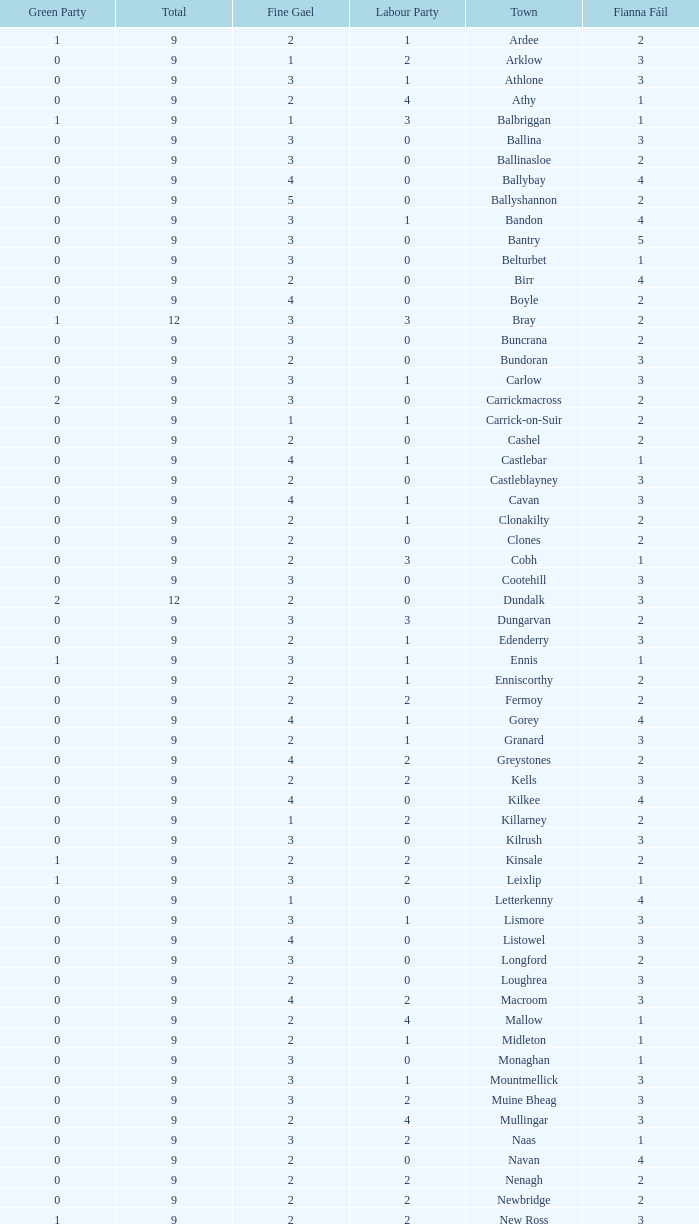How many are in the Labour Party of a Fianna Fail of 3 with a total higher than 9 and more than 2 in the Green Party? None. Could you parse the entire table as a dict? {'header': ['Green Party', 'Total', 'Fine Gael', 'Labour Party', 'Town', 'Fianna Fáil'], 'rows': [['1', '9', '2', '1', 'Ardee', '2'], ['0', '9', '1', '2', 'Arklow', '3'], ['0', '9', '3', '1', 'Athlone', '3'], ['0', '9', '2', '4', 'Athy', '1'], ['1', '9', '1', '3', 'Balbriggan', '1'], ['0', '9', '3', '0', 'Ballina', '3'], ['0', '9', '3', '0', 'Ballinasloe', '2'], ['0', '9', '4', '0', 'Ballybay', '4'], ['0', '9', '5', '0', 'Ballyshannon', '2'], ['0', '9', '3', '1', 'Bandon', '4'], ['0', '9', '3', '0', 'Bantry', '5'], ['0', '9', '3', '0', 'Belturbet', '1'], ['0', '9', '2', '0', 'Birr', '4'], ['0', '9', '4', '0', 'Boyle', '2'], ['1', '12', '3', '3', 'Bray', '2'], ['0', '9', '3', '0', 'Buncrana', '2'], ['0', '9', '2', '0', 'Bundoran', '3'], ['0', '9', '3', '1', 'Carlow', '3'], ['2', '9', '3', '0', 'Carrickmacross', '2'], ['0', '9', '1', '1', 'Carrick-on-Suir', '2'], ['0', '9', '2', '0', 'Cashel', '2'], ['0', '9', '4', '1', 'Castlebar', '1'], ['0', '9', '2', '0', 'Castleblayney', '3'], ['0', '9', '4', '1', 'Cavan', '3'], ['0', '9', '2', '1', 'Clonakilty', '2'], ['0', '9', '2', '0', 'Clones', '2'], ['0', '9', '2', '3', 'Cobh', '1'], ['0', '9', '3', '0', 'Cootehill', '3'], ['2', '12', '2', '0', 'Dundalk', '3'], ['0', '9', '3', '3', 'Dungarvan', '2'], ['0', '9', '2', '1', 'Edenderry', '3'], ['1', '9', '3', '1', 'Ennis', '1'], ['0', '9', '2', '1', 'Enniscorthy', '2'], ['0', '9', '2', '2', 'Fermoy', '2'], ['0', '9', '4', '1', 'Gorey', '4'], ['0', '9', '2', '1', 'Granard', '3'], ['0', '9', '4', '2', 'Greystones', '2'], ['0', '9', '2', '2', 'Kells', '3'], ['0', '9', '4', '0', 'Kilkee', '4'], ['0', '9', '1', '2', 'Killarney', '2'], ['0', '9', '3', '0', 'Kilrush', '3'], ['1', '9', '2', '2', 'Kinsale', '2'], ['1', '9', '3', '2', 'Leixlip', '1'], ['0', '9', '1', '0', 'Letterkenny', '4'], ['0', '9', '3', '1', 'Lismore', '3'], ['0', '9', '4', '0', 'Listowel', '3'], ['0', '9', '3', '0', 'Longford', '2'], ['0', '9', '2', '0', 'Loughrea', '3'], ['0', '9', '4', '2', 'Macroom', '3'], ['0', '9', '2', '4', 'Mallow', '1'], ['0', '9', '2', '1', 'Midleton', '1'], ['0', '9', '3', '0', 'Monaghan', '1'], ['0', '9', '3', '1', 'Mountmellick', '3'], ['0', '9', '3', '2', 'Muine Bheag', '3'], ['0', '9', '2', '4', 'Mullingar', '3'], ['0', '9', '3', '2', 'Naas', '1'], ['0', '9', '2', '0', 'Navan', '4'], ['0', '9', '2', '2', 'Nenagh', '2'], ['0', '9', '2', '2', 'Newbridge', '2'], ['1', '9', '2', '2', 'New Ross', '3'], ['0', '9', '3', '0', 'Passage West', '2'], ['0', '9', '3', '0', 'Portlaoise', '2'], ['0', '9', '4', '2', 'Shannon', '0'], ['0', '9', '4', '2', 'Skibbereen', '2'], ['0', '9', '3', '0', 'Templemore', '3'], ['0', '9', '1', '2', 'Thurles', '1'], ['0', '9', '1', '1', 'Tipperary', '3'], ['0', '12', '3', '3', 'Tralee', '2'], ['0', '9', '4', '1', 'Tramore', '1'], ['0', '9', '3', '2', 'Trim', '2'], ['0', '9', '2', '2', 'Tuam', '3'], ['0', '9', '2', '2', 'Tullamore', '4'], ['0', '9', '5', '1', 'Westport', '2'], ['1', '9', '3', '1', 'Wicklow', '1'], ['1', '9', '2', '1', 'Youghal', '3']]} 